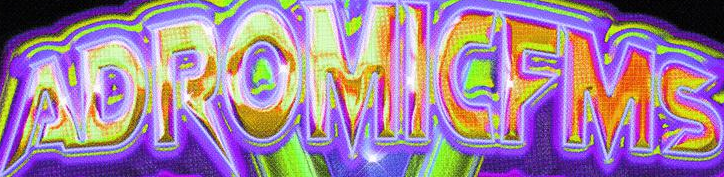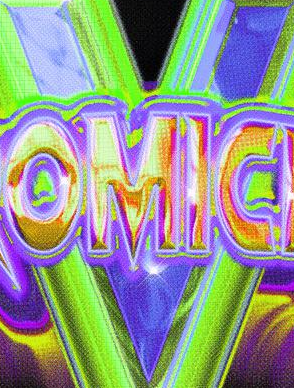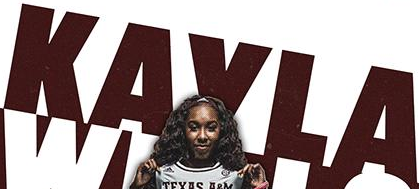Read the text content from these images in order, separated by a semicolon. ADROMICFMS; V; KAVLA 